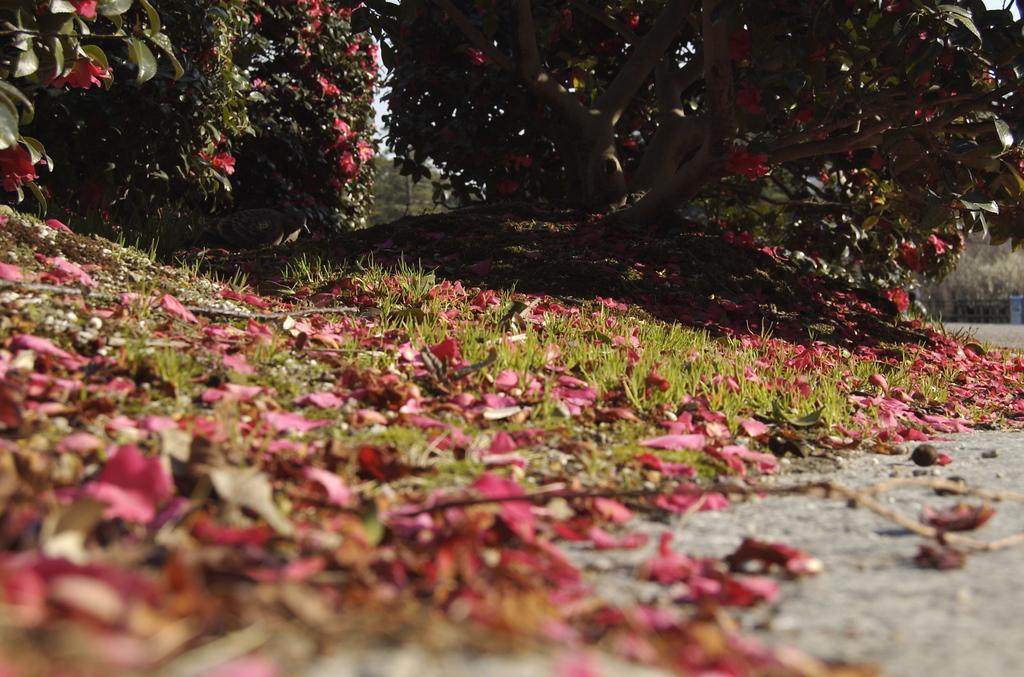Can you describe this image briefly? In this picture there are flower petals and grassland in the center of the image and there are flower plants at the top side of the image. 